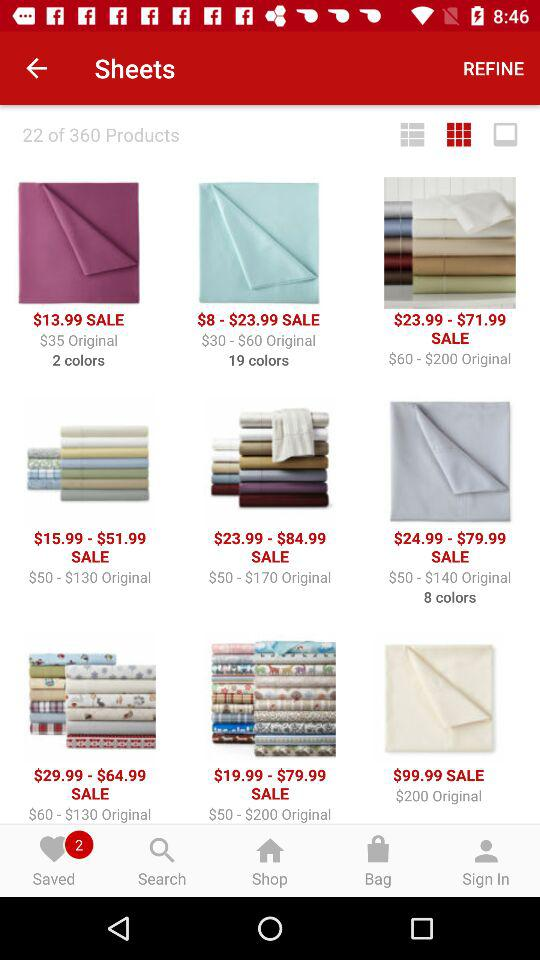How many products in total are there? There are 360 products in total. 